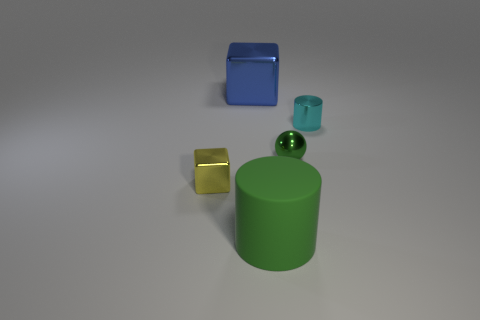Add 4 large matte cylinders. How many objects exist? 9 Subtract all cubes. How many objects are left? 3 Subtract 0 cyan cubes. How many objects are left? 5 Subtract all cyan balls. Subtract all brown blocks. How many balls are left? 1 Subtract all green shiny spheres. Subtract all tiny purple matte cylinders. How many objects are left? 4 Add 2 green metallic balls. How many green metallic balls are left? 3 Add 3 small purple cylinders. How many small purple cylinders exist? 3 